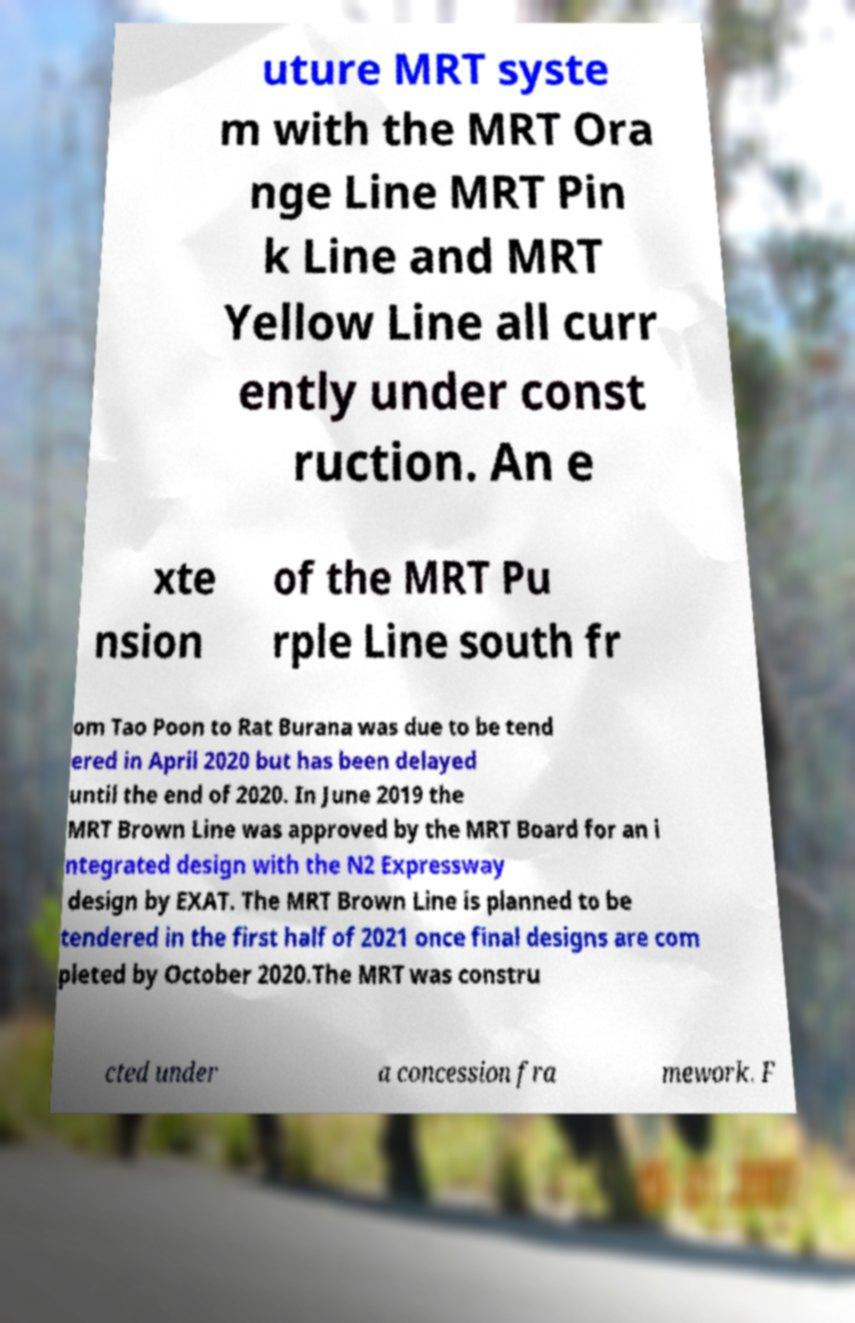I need the written content from this picture converted into text. Can you do that? uture MRT syste m with the MRT Ora nge Line MRT Pin k Line and MRT Yellow Line all curr ently under const ruction. An e xte nsion of the MRT Pu rple Line south fr om Tao Poon to Rat Burana was due to be tend ered in April 2020 but has been delayed until the end of 2020. In June 2019 the MRT Brown Line was approved by the MRT Board for an i ntegrated design with the N2 Expressway design by EXAT. The MRT Brown Line is planned to be tendered in the first half of 2021 once final designs are com pleted by October 2020.The MRT was constru cted under a concession fra mework. F 